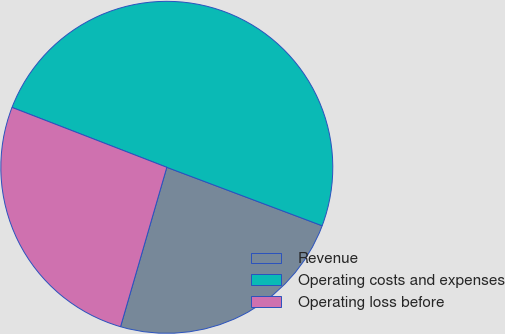<chart> <loc_0><loc_0><loc_500><loc_500><pie_chart><fcel>Revenue<fcel>Operating costs and expenses<fcel>Operating loss before<nl><fcel>23.77%<fcel>49.85%<fcel>26.38%<nl></chart> 